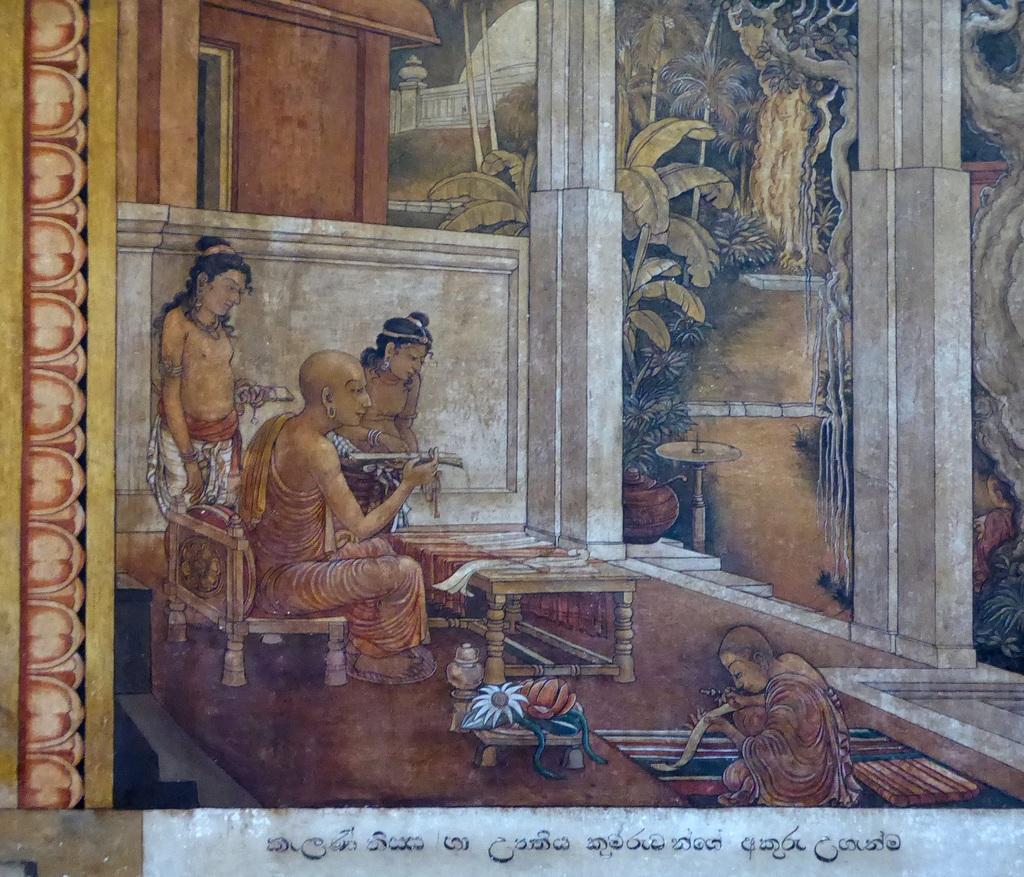Please provide a concise description of this image. In this picture I can see painting on the board or on the wall, there are four people, there are trees and some other objects in the painting, there are some words on the wall or on the board. 